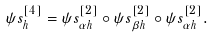<formula> <loc_0><loc_0><loc_500><loc_500>\psi s _ { h } ^ { [ 4 ] } = \psi s _ { \alpha h } ^ { [ 2 ] } \circ \psi s _ { \beta h } ^ { [ 2 ] } \circ \psi s _ { \alpha h } ^ { [ 2 ] } .</formula> 